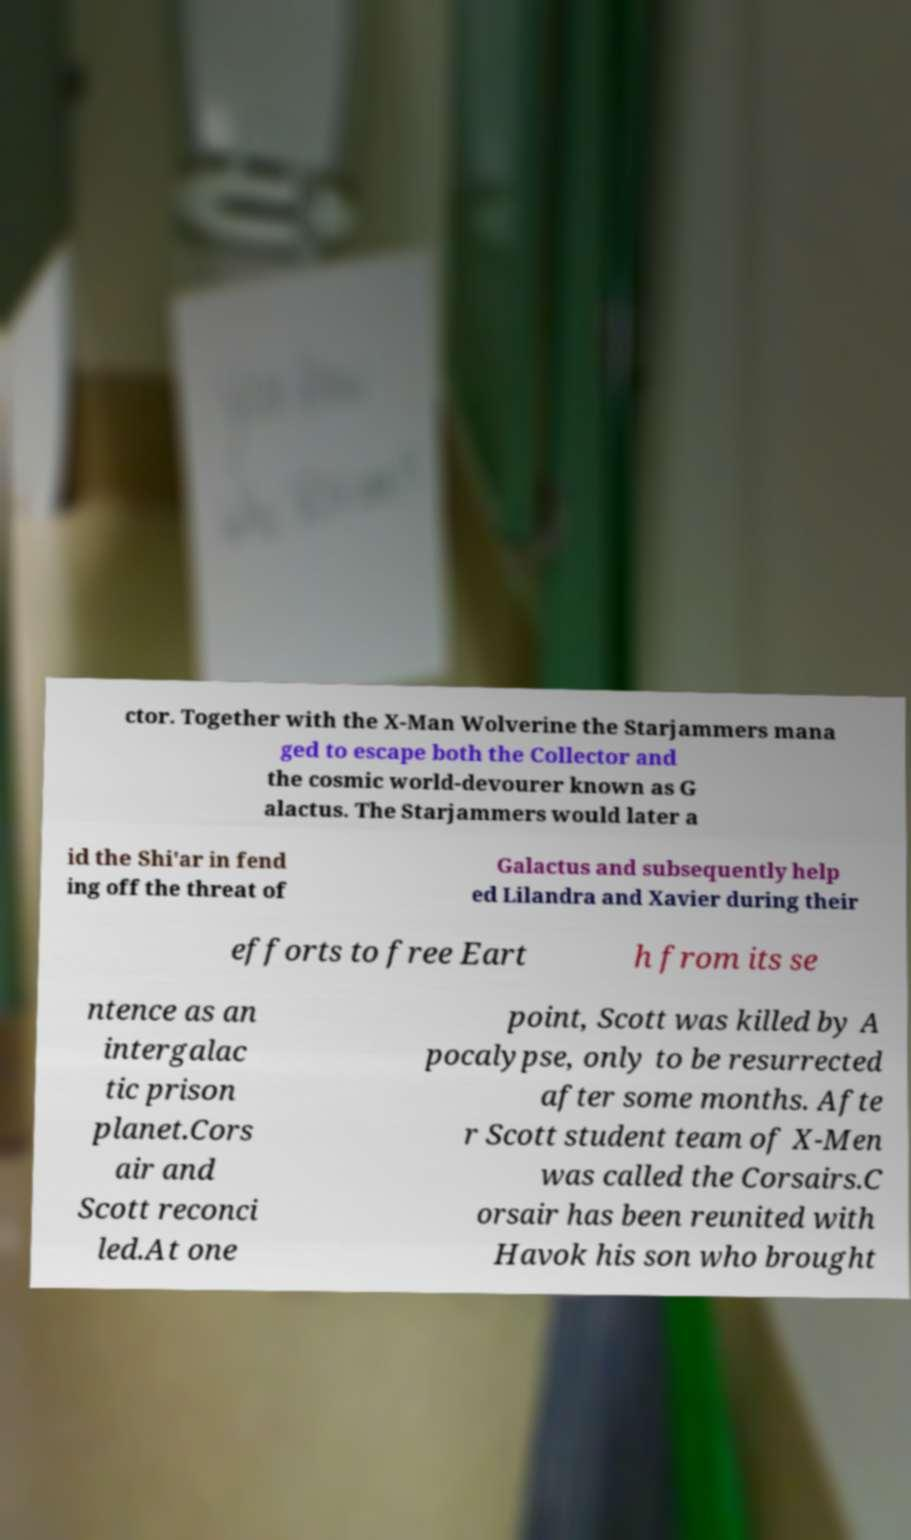Can you accurately transcribe the text from the provided image for me? ctor. Together with the X-Man Wolverine the Starjammers mana ged to escape both the Collector and the cosmic world-devourer known as G alactus. The Starjammers would later a id the Shi'ar in fend ing off the threat of Galactus and subsequently help ed Lilandra and Xavier during their efforts to free Eart h from its se ntence as an intergalac tic prison planet.Cors air and Scott reconci led.At one point, Scott was killed by A pocalypse, only to be resurrected after some months. Afte r Scott student team of X-Men was called the Corsairs.C orsair has been reunited with Havok his son who brought 